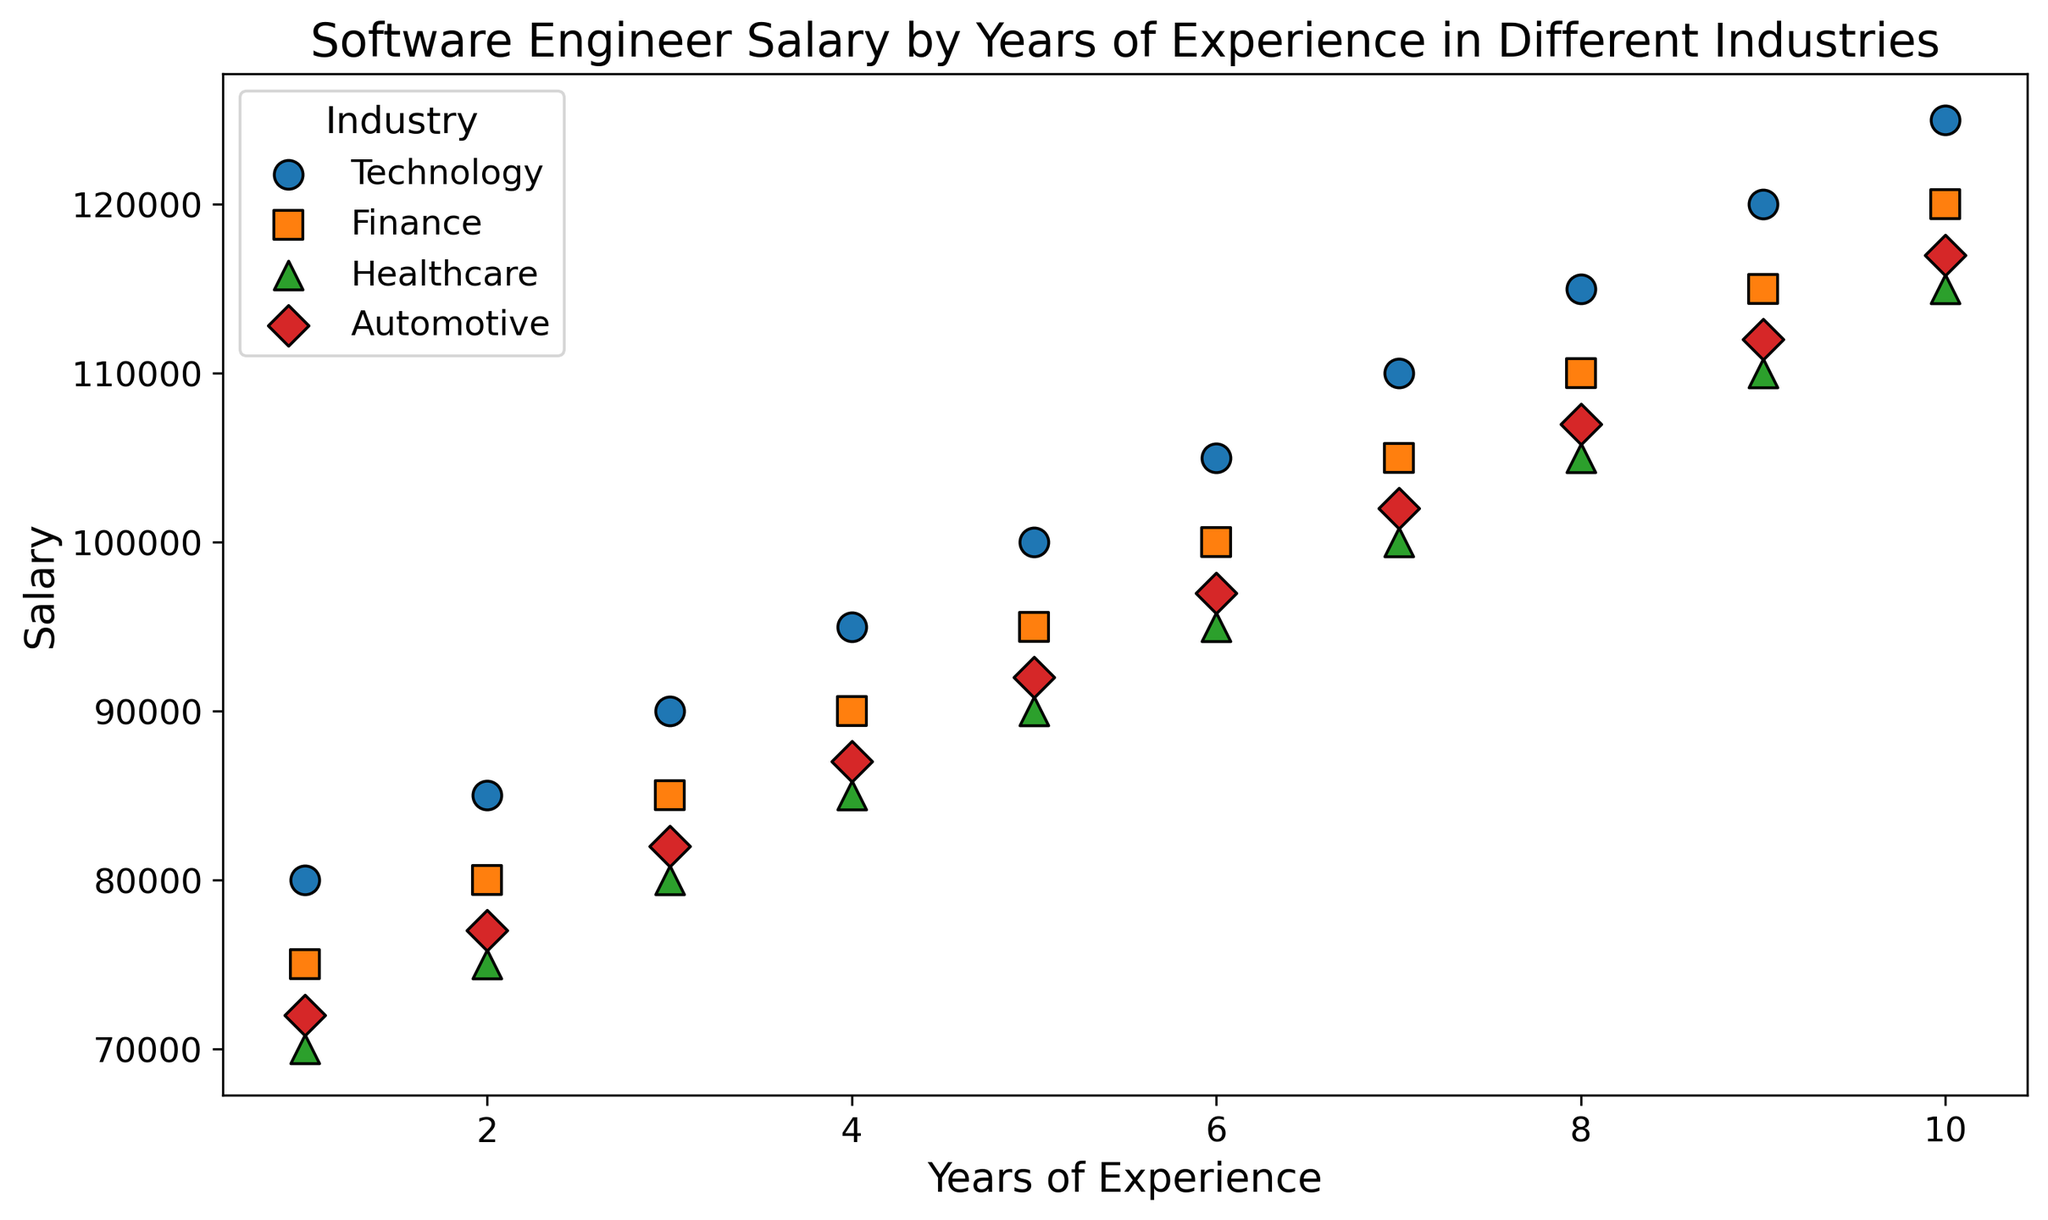Which industry generally shows the highest starting salary for software engineers? By observing the starting salary (1 year of experience) for all industries, Technology has a starting salary of 80,000, Finance 75,000, Healthcare 70,000, and Automotive 72,000. Technology has the highest starting salary.
Answer: Technology Which industry shows the steepest increase in salary from 1 year to 10 years of experience? To determine the steepest increase, observe the difference in salaries between 1 year and 10 years of experience for each industry. Technology increases from 80,000 to 125,000 (45,000 difference), Finance from 75,000 to 120,000 (45,000), Healthcare from 70,000 to 115,000 (45,000), and Automotive from 72,000 to 117,000 (45,000). All industries show the same increase.
Answer: All industries (equal increase) Between Finance and Healthcare, which industry has a lower average salary over the 10-year span? Calculate the average salary for both industries over the 10 years. For Finance, the sum of salaries is 75,000+80,000+85,000+90,000+95,000+100,000+105,000+110,000+115,000+120,000 = 975,000/10 = 97,500. For Healthcare, the sum is 70,000+75,000+80,000+85,000+90,000+95,000+100,000+105,000+110,000+115,000 = 925,000/10 = 92,500. Healthcare has a lower average salary.
Answer: Healthcare By how much does the average salary of software engineers in the Technology industry exceed that in the Automotive industry after 5 years of experience? Average salary after 5 years for Technology = (80,000 + 85,000 + 90,000 + 95,000 + 100,000 + 105,000 + 110,000 + 115,000 + 120,000 + 125,000)/10 = 102,500. For Automotive = (72,000 + 77,000 + 82,000 + 87,000 + 92,000 + 97,000 + 102,000 + 107,000 + 112,000 + 117,000)/10 = 94,500. Difference: 102,500 - 94,500 = 8,000.
Answer: 8,000 How does the salary growth in the Healthcare industry from 5 years to 10 years of experience compare to Finance in the same period? Growth for Healthcare: 115,000 - 90,000 = 25,000. Growth for Finance: 120,000 - 95,000 = 25,000. Both have the same growth.
Answer: Same Looking at the graph, which industry has the most consistent salary increase trend? Observe the scatter plot points for each industry. All industries show a consistent increase, but there should be no unexpected jumps or declines. Visual analysis indicates a consistent pattern in all four industries.
Answer: All industries Which industry shows the greatest variation in salaries for software engineers compared to their years of experience? By observing the scatter plot, analyze the spread of data points. All industries seem to grow linearly without much variation. Thus, no industry shows considerable variation.
Answer: None 